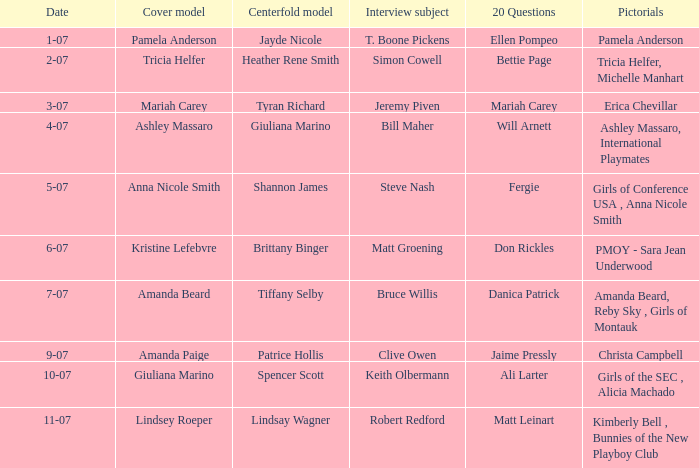Who was the centerfold model in the issue where Fergie answered the "20 questions"? Shannon James. 